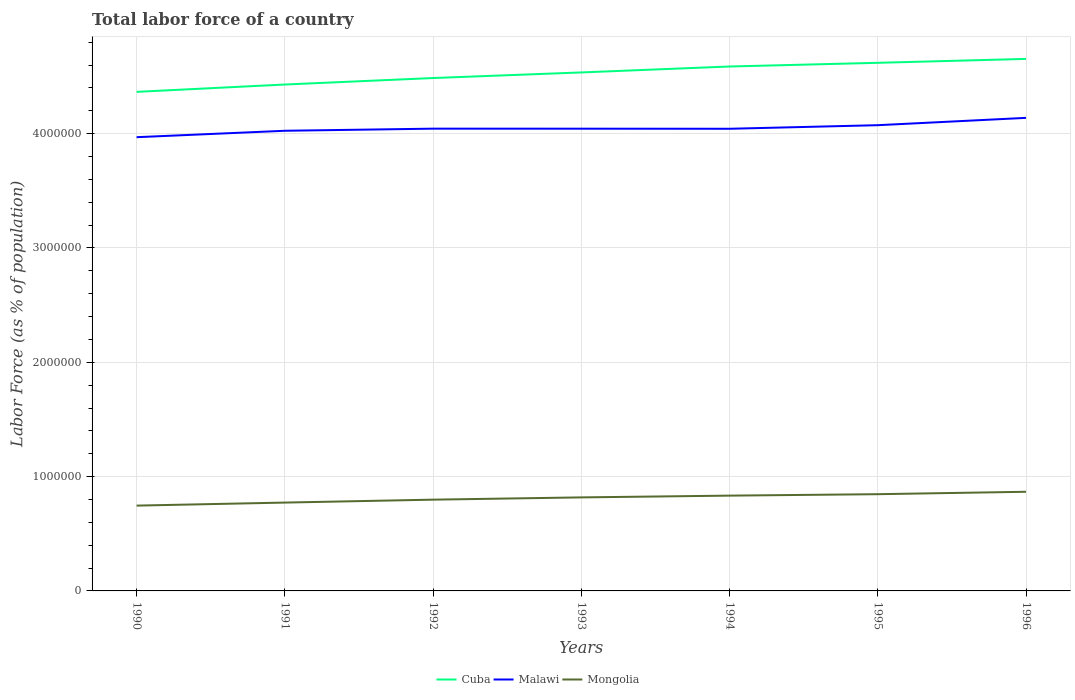How many different coloured lines are there?
Your response must be concise. 3. Does the line corresponding to Cuba intersect with the line corresponding to Malawi?
Your response must be concise. No. Across all years, what is the maximum percentage of labor force in Malawi?
Give a very brief answer. 3.97e+06. In which year was the percentage of labor force in Cuba maximum?
Your answer should be very brief. 1990. What is the total percentage of labor force in Malawi in the graph?
Offer a terse response. 359. What is the difference between the highest and the second highest percentage of labor force in Cuba?
Make the answer very short. 2.88e+05. Does the graph contain any zero values?
Give a very brief answer. No. Does the graph contain grids?
Provide a short and direct response. Yes. What is the title of the graph?
Offer a very short reply. Total labor force of a country. Does "Albania" appear as one of the legend labels in the graph?
Offer a very short reply. No. What is the label or title of the X-axis?
Your answer should be compact. Years. What is the label or title of the Y-axis?
Your answer should be very brief. Labor Force (as % of population). What is the Labor Force (as % of population) in Cuba in 1990?
Make the answer very short. 4.37e+06. What is the Labor Force (as % of population) in Malawi in 1990?
Offer a very short reply. 3.97e+06. What is the Labor Force (as % of population) in Mongolia in 1990?
Your response must be concise. 7.46e+05. What is the Labor Force (as % of population) in Cuba in 1991?
Keep it short and to the point. 4.43e+06. What is the Labor Force (as % of population) of Malawi in 1991?
Make the answer very short. 4.03e+06. What is the Labor Force (as % of population) of Mongolia in 1991?
Provide a short and direct response. 7.73e+05. What is the Labor Force (as % of population) in Cuba in 1992?
Offer a terse response. 4.49e+06. What is the Labor Force (as % of population) of Malawi in 1992?
Your response must be concise. 4.04e+06. What is the Labor Force (as % of population) in Mongolia in 1992?
Provide a short and direct response. 7.98e+05. What is the Labor Force (as % of population) of Cuba in 1993?
Keep it short and to the point. 4.54e+06. What is the Labor Force (as % of population) of Malawi in 1993?
Give a very brief answer. 4.04e+06. What is the Labor Force (as % of population) of Mongolia in 1993?
Keep it short and to the point. 8.18e+05. What is the Labor Force (as % of population) of Cuba in 1994?
Provide a succinct answer. 4.59e+06. What is the Labor Force (as % of population) of Malawi in 1994?
Provide a short and direct response. 4.04e+06. What is the Labor Force (as % of population) of Mongolia in 1994?
Ensure brevity in your answer.  8.34e+05. What is the Labor Force (as % of population) of Cuba in 1995?
Your answer should be compact. 4.62e+06. What is the Labor Force (as % of population) in Malawi in 1995?
Make the answer very short. 4.07e+06. What is the Labor Force (as % of population) of Mongolia in 1995?
Offer a very short reply. 8.46e+05. What is the Labor Force (as % of population) in Cuba in 1996?
Provide a succinct answer. 4.65e+06. What is the Labor Force (as % of population) in Malawi in 1996?
Offer a very short reply. 4.14e+06. What is the Labor Force (as % of population) of Mongolia in 1996?
Make the answer very short. 8.67e+05. Across all years, what is the maximum Labor Force (as % of population) of Cuba?
Provide a succinct answer. 4.65e+06. Across all years, what is the maximum Labor Force (as % of population) of Malawi?
Offer a terse response. 4.14e+06. Across all years, what is the maximum Labor Force (as % of population) in Mongolia?
Ensure brevity in your answer.  8.67e+05. Across all years, what is the minimum Labor Force (as % of population) of Cuba?
Keep it short and to the point. 4.37e+06. Across all years, what is the minimum Labor Force (as % of population) in Malawi?
Your answer should be very brief. 3.97e+06. Across all years, what is the minimum Labor Force (as % of population) of Mongolia?
Your response must be concise. 7.46e+05. What is the total Labor Force (as % of population) of Cuba in the graph?
Provide a succinct answer. 3.17e+07. What is the total Labor Force (as % of population) in Malawi in the graph?
Your response must be concise. 2.83e+07. What is the total Labor Force (as % of population) of Mongolia in the graph?
Your response must be concise. 5.68e+06. What is the difference between the Labor Force (as % of population) in Cuba in 1990 and that in 1991?
Ensure brevity in your answer.  -6.43e+04. What is the difference between the Labor Force (as % of population) in Malawi in 1990 and that in 1991?
Make the answer very short. -5.61e+04. What is the difference between the Labor Force (as % of population) in Mongolia in 1990 and that in 1991?
Provide a short and direct response. -2.65e+04. What is the difference between the Labor Force (as % of population) of Cuba in 1990 and that in 1992?
Your answer should be very brief. -1.21e+05. What is the difference between the Labor Force (as % of population) of Malawi in 1990 and that in 1992?
Make the answer very short. -7.47e+04. What is the difference between the Labor Force (as % of population) in Mongolia in 1990 and that in 1992?
Offer a terse response. -5.20e+04. What is the difference between the Labor Force (as % of population) of Cuba in 1990 and that in 1993?
Ensure brevity in your answer.  -1.70e+05. What is the difference between the Labor Force (as % of population) in Malawi in 1990 and that in 1993?
Provide a short and direct response. -7.43e+04. What is the difference between the Labor Force (as % of population) in Mongolia in 1990 and that in 1993?
Offer a very short reply. -7.19e+04. What is the difference between the Labor Force (as % of population) of Cuba in 1990 and that in 1994?
Give a very brief answer. -2.22e+05. What is the difference between the Labor Force (as % of population) of Malawi in 1990 and that in 1994?
Offer a very short reply. -7.36e+04. What is the difference between the Labor Force (as % of population) in Mongolia in 1990 and that in 1994?
Offer a terse response. -8.73e+04. What is the difference between the Labor Force (as % of population) in Cuba in 1990 and that in 1995?
Your answer should be very brief. -2.54e+05. What is the difference between the Labor Force (as % of population) of Malawi in 1990 and that in 1995?
Your response must be concise. -1.05e+05. What is the difference between the Labor Force (as % of population) in Mongolia in 1990 and that in 1995?
Your answer should be very brief. -9.99e+04. What is the difference between the Labor Force (as % of population) in Cuba in 1990 and that in 1996?
Provide a short and direct response. -2.88e+05. What is the difference between the Labor Force (as % of population) of Malawi in 1990 and that in 1996?
Your answer should be compact. -1.69e+05. What is the difference between the Labor Force (as % of population) in Mongolia in 1990 and that in 1996?
Offer a terse response. -1.21e+05. What is the difference between the Labor Force (as % of population) of Cuba in 1991 and that in 1992?
Give a very brief answer. -5.67e+04. What is the difference between the Labor Force (as % of population) in Malawi in 1991 and that in 1992?
Ensure brevity in your answer.  -1.86e+04. What is the difference between the Labor Force (as % of population) in Mongolia in 1991 and that in 1992?
Keep it short and to the point. -2.54e+04. What is the difference between the Labor Force (as % of population) of Cuba in 1991 and that in 1993?
Your response must be concise. -1.06e+05. What is the difference between the Labor Force (as % of population) in Malawi in 1991 and that in 1993?
Offer a terse response. -1.82e+04. What is the difference between the Labor Force (as % of population) of Mongolia in 1991 and that in 1993?
Provide a short and direct response. -4.54e+04. What is the difference between the Labor Force (as % of population) in Cuba in 1991 and that in 1994?
Your answer should be compact. -1.58e+05. What is the difference between the Labor Force (as % of population) in Malawi in 1991 and that in 1994?
Your answer should be compact. -1.75e+04. What is the difference between the Labor Force (as % of population) in Mongolia in 1991 and that in 1994?
Your response must be concise. -6.08e+04. What is the difference between the Labor Force (as % of population) of Cuba in 1991 and that in 1995?
Offer a very short reply. -1.90e+05. What is the difference between the Labor Force (as % of population) in Malawi in 1991 and that in 1995?
Make the answer very short. -4.89e+04. What is the difference between the Labor Force (as % of population) in Mongolia in 1991 and that in 1995?
Offer a very short reply. -7.34e+04. What is the difference between the Labor Force (as % of population) of Cuba in 1991 and that in 1996?
Ensure brevity in your answer.  -2.24e+05. What is the difference between the Labor Force (as % of population) in Malawi in 1991 and that in 1996?
Your answer should be very brief. -1.13e+05. What is the difference between the Labor Force (as % of population) of Mongolia in 1991 and that in 1996?
Give a very brief answer. -9.45e+04. What is the difference between the Labor Force (as % of population) in Cuba in 1992 and that in 1993?
Provide a short and direct response. -4.89e+04. What is the difference between the Labor Force (as % of population) in Malawi in 1992 and that in 1993?
Provide a succinct answer. 359. What is the difference between the Labor Force (as % of population) of Mongolia in 1992 and that in 1993?
Your response must be concise. -1.99e+04. What is the difference between the Labor Force (as % of population) in Cuba in 1992 and that in 1994?
Keep it short and to the point. -1.01e+05. What is the difference between the Labor Force (as % of population) in Malawi in 1992 and that in 1994?
Give a very brief answer. 1039. What is the difference between the Labor Force (as % of population) in Mongolia in 1992 and that in 1994?
Ensure brevity in your answer.  -3.53e+04. What is the difference between the Labor Force (as % of population) in Cuba in 1992 and that in 1995?
Make the answer very short. -1.33e+05. What is the difference between the Labor Force (as % of population) of Malawi in 1992 and that in 1995?
Provide a succinct answer. -3.03e+04. What is the difference between the Labor Force (as % of population) in Mongolia in 1992 and that in 1995?
Offer a very short reply. -4.79e+04. What is the difference between the Labor Force (as % of population) in Cuba in 1992 and that in 1996?
Make the answer very short. -1.67e+05. What is the difference between the Labor Force (as % of population) of Malawi in 1992 and that in 1996?
Provide a succinct answer. -9.44e+04. What is the difference between the Labor Force (as % of population) of Mongolia in 1992 and that in 1996?
Your answer should be very brief. -6.90e+04. What is the difference between the Labor Force (as % of population) of Cuba in 1993 and that in 1994?
Make the answer very short. -5.19e+04. What is the difference between the Labor Force (as % of population) of Malawi in 1993 and that in 1994?
Offer a terse response. 680. What is the difference between the Labor Force (as % of population) in Mongolia in 1993 and that in 1994?
Keep it short and to the point. -1.54e+04. What is the difference between the Labor Force (as % of population) of Cuba in 1993 and that in 1995?
Provide a short and direct response. -8.42e+04. What is the difference between the Labor Force (as % of population) of Malawi in 1993 and that in 1995?
Your response must be concise. -3.06e+04. What is the difference between the Labor Force (as % of population) of Mongolia in 1993 and that in 1995?
Make the answer very short. -2.80e+04. What is the difference between the Labor Force (as % of population) of Cuba in 1993 and that in 1996?
Provide a succinct answer. -1.18e+05. What is the difference between the Labor Force (as % of population) of Malawi in 1993 and that in 1996?
Ensure brevity in your answer.  -9.48e+04. What is the difference between the Labor Force (as % of population) in Mongolia in 1993 and that in 1996?
Your response must be concise. -4.91e+04. What is the difference between the Labor Force (as % of population) of Cuba in 1994 and that in 1995?
Give a very brief answer. -3.23e+04. What is the difference between the Labor Force (as % of population) in Malawi in 1994 and that in 1995?
Offer a very short reply. -3.13e+04. What is the difference between the Labor Force (as % of population) of Mongolia in 1994 and that in 1995?
Your answer should be very brief. -1.26e+04. What is the difference between the Labor Force (as % of population) of Cuba in 1994 and that in 1996?
Your answer should be very brief. -6.64e+04. What is the difference between the Labor Force (as % of population) of Malawi in 1994 and that in 1996?
Provide a succinct answer. -9.55e+04. What is the difference between the Labor Force (as % of population) of Mongolia in 1994 and that in 1996?
Offer a terse response. -3.37e+04. What is the difference between the Labor Force (as % of population) in Cuba in 1995 and that in 1996?
Your answer should be compact. -3.42e+04. What is the difference between the Labor Force (as % of population) in Malawi in 1995 and that in 1996?
Your answer should be compact. -6.41e+04. What is the difference between the Labor Force (as % of population) in Mongolia in 1995 and that in 1996?
Keep it short and to the point. -2.11e+04. What is the difference between the Labor Force (as % of population) of Cuba in 1990 and the Labor Force (as % of population) of Malawi in 1991?
Keep it short and to the point. 3.40e+05. What is the difference between the Labor Force (as % of population) of Cuba in 1990 and the Labor Force (as % of population) of Mongolia in 1991?
Your response must be concise. 3.59e+06. What is the difference between the Labor Force (as % of population) of Malawi in 1990 and the Labor Force (as % of population) of Mongolia in 1991?
Provide a short and direct response. 3.20e+06. What is the difference between the Labor Force (as % of population) in Cuba in 1990 and the Labor Force (as % of population) in Malawi in 1992?
Offer a very short reply. 3.22e+05. What is the difference between the Labor Force (as % of population) in Cuba in 1990 and the Labor Force (as % of population) in Mongolia in 1992?
Make the answer very short. 3.57e+06. What is the difference between the Labor Force (as % of population) of Malawi in 1990 and the Labor Force (as % of population) of Mongolia in 1992?
Keep it short and to the point. 3.17e+06. What is the difference between the Labor Force (as % of population) in Cuba in 1990 and the Labor Force (as % of population) in Malawi in 1993?
Your answer should be very brief. 3.22e+05. What is the difference between the Labor Force (as % of population) of Cuba in 1990 and the Labor Force (as % of population) of Mongolia in 1993?
Ensure brevity in your answer.  3.55e+06. What is the difference between the Labor Force (as % of population) of Malawi in 1990 and the Labor Force (as % of population) of Mongolia in 1993?
Your answer should be compact. 3.15e+06. What is the difference between the Labor Force (as % of population) in Cuba in 1990 and the Labor Force (as % of population) in Malawi in 1994?
Provide a succinct answer. 3.23e+05. What is the difference between the Labor Force (as % of population) of Cuba in 1990 and the Labor Force (as % of population) of Mongolia in 1994?
Offer a terse response. 3.53e+06. What is the difference between the Labor Force (as % of population) in Malawi in 1990 and the Labor Force (as % of population) in Mongolia in 1994?
Your response must be concise. 3.14e+06. What is the difference between the Labor Force (as % of population) in Cuba in 1990 and the Labor Force (as % of population) in Malawi in 1995?
Provide a short and direct response. 2.92e+05. What is the difference between the Labor Force (as % of population) of Cuba in 1990 and the Labor Force (as % of population) of Mongolia in 1995?
Keep it short and to the point. 3.52e+06. What is the difference between the Labor Force (as % of population) in Malawi in 1990 and the Labor Force (as % of population) in Mongolia in 1995?
Give a very brief answer. 3.12e+06. What is the difference between the Labor Force (as % of population) of Cuba in 1990 and the Labor Force (as % of population) of Malawi in 1996?
Your answer should be compact. 2.27e+05. What is the difference between the Labor Force (as % of population) in Cuba in 1990 and the Labor Force (as % of population) in Mongolia in 1996?
Offer a very short reply. 3.50e+06. What is the difference between the Labor Force (as % of population) in Malawi in 1990 and the Labor Force (as % of population) in Mongolia in 1996?
Your answer should be compact. 3.10e+06. What is the difference between the Labor Force (as % of population) in Cuba in 1991 and the Labor Force (as % of population) in Malawi in 1992?
Your answer should be very brief. 3.86e+05. What is the difference between the Labor Force (as % of population) of Cuba in 1991 and the Labor Force (as % of population) of Mongolia in 1992?
Offer a terse response. 3.63e+06. What is the difference between the Labor Force (as % of population) of Malawi in 1991 and the Labor Force (as % of population) of Mongolia in 1992?
Your answer should be compact. 3.23e+06. What is the difference between the Labor Force (as % of population) of Cuba in 1991 and the Labor Force (as % of population) of Malawi in 1993?
Provide a succinct answer. 3.86e+05. What is the difference between the Labor Force (as % of population) in Cuba in 1991 and the Labor Force (as % of population) in Mongolia in 1993?
Your answer should be very brief. 3.61e+06. What is the difference between the Labor Force (as % of population) of Malawi in 1991 and the Labor Force (as % of population) of Mongolia in 1993?
Make the answer very short. 3.21e+06. What is the difference between the Labor Force (as % of population) of Cuba in 1991 and the Labor Force (as % of population) of Malawi in 1994?
Your answer should be compact. 3.87e+05. What is the difference between the Labor Force (as % of population) of Cuba in 1991 and the Labor Force (as % of population) of Mongolia in 1994?
Keep it short and to the point. 3.60e+06. What is the difference between the Labor Force (as % of population) of Malawi in 1991 and the Labor Force (as % of population) of Mongolia in 1994?
Offer a very short reply. 3.19e+06. What is the difference between the Labor Force (as % of population) of Cuba in 1991 and the Labor Force (as % of population) of Malawi in 1995?
Offer a terse response. 3.56e+05. What is the difference between the Labor Force (as % of population) of Cuba in 1991 and the Labor Force (as % of population) of Mongolia in 1995?
Make the answer very short. 3.58e+06. What is the difference between the Labor Force (as % of population) of Malawi in 1991 and the Labor Force (as % of population) of Mongolia in 1995?
Ensure brevity in your answer.  3.18e+06. What is the difference between the Labor Force (as % of population) of Cuba in 1991 and the Labor Force (as % of population) of Malawi in 1996?
Your answer should be compact. 2.92e+05. What is the difference between the Labor Force (as % of population) of Cuba in 1991 and the Labor Force (as % of population) of Mongolia in 1996?
Offer a very short reply. 3.56e+06. What is the difference between the Labor Force (as % of population) of Malawi in 1991 and the Labor Force (as % of population) of Mongolia in 1996?
Provide a succinct answer. 3.16e+06. What is the difference between the Labor Force (as % of population) in Cuba in 1992 and the Labor Force (as % of population) in Malawi in 1993?
Ensure brevity in your answer.  4.43e+05. What is the difference between the Labor Force (as % of population) in Cuba in 1992 and the Labor Force (as % of population) in Mongolia in 1993?
Keep it short and to the point. 3.67e+06. What is the difference between the Labor Force (as % of population) in Malawi in 1992 and the Labor Force (as % of population) in Mongolia in 1993?
Offer a terse response. 3.23e+06. What is the difference between the Labor Force (as % of population) in Cuba in 1992 and the Labor Force (as % of population) in Malawi in 1994?
Give a very brief answer. 4.44e+05. What is the difference between the Labor Force (as % of population) of Cuba in 1992 and the Labor Force (as % of population) of Mongolia in 1994?
Provide a succinct answer. 3.65e+06. What is the difference between the Labor Force (as % of population) of Malawi in 1992 and the Labor Force (as % of population) of Mongolia in 1994?
Provide a short and direct response. 3.21e+06. What is the difference between the Labor Force (as % of population) of Cuba in 1992 and the Labor Force (as % of population) of Malawi in 1995?
Your response must be concise. 4.13e+05. What is the difference between the Labor Force (as % of population) in Cuba in 1992 and the Labor Force (as % of population) in Mongolia in 1995?
Offer a very short reply. 3.64e+06. What is the difference between the Labor Force (as % of population) in Malawi in 1992 and the Labor Force (as % of population) in Mongolia in 1995?
Keep it short and to the point. 3.20e+06. What is the difference between the Labor Force (as % of population) of Cuba in 1992 and the Labor Force (as % of population) of Malawi in 1996?
Provide a short and direct response. 3.48e+05. What is the difference between the Labor Force (as % of population) of Cuba in 1992 and the Labor Force (as % of population) of Mongolia in 1996?
Your answer should be compact. 3.62e+06. What is the difference between the Labor Force (as % of population) in Malawi in 1992 and the Labor Force (as % of population) in Mongolia in 1996?
Your response must be concise. 3.18e+06. What is the difference between the Labor Force (as % of population) of Cuba in 1993 and the Labor Force (as % of population) of Malawi in 1994?
Your answer should be compact. 4.93e+05. What is the difference between the Labor Force (as % of population) in Cuba in 1993 and the Labor Force (as % of population) in Mongolia in 1994?
Provide a succinct answer. 3.70e+06. What is the difference between the Labor Force (as % of population) of Malawi in 1993 and the Labor Force (as % of population) of Mongolia in 1994?
Ensure brevity in your answer.  3.21e+06. What is the difference between the Labor Force (as % of population) in Cuba in 1993 and the Labor Force (as % of population) in Malawi in 1995?
Ensure brevity in your answer.  4.61e+05. What is the difference between the Labor Force (as % of population) of Cuba in 1993 and the Labor Force (as % of population) of Mongolia in 1995?
Offer a terse response. 3.69e+06. What is the difference between the Labor Force (as % of population) of Malawi in 1993 and the Labor Force (as % of population) of Mongolia in 1995?
Offer a terse response. 3.20e+06. What is the difference between the Labor Force (as % of population) in Cuba in 1993 and the Labor Force (as % of population) in Malawi in 1996?
Keep it short and to the point. 3.97e+05. What is the difference between the Labor Force (as % of population) of Cuba in 1993 and the Labor Force (as % of population) of Mongolia in 1996?
Keep it short and to the point. 3.67e+06. What is the difference between the Labor Force (as % of population) of Malawi in 1993 and the Labor Force (as % of population) of Mongolia in 1996?
Your answer should be very brief. 3.18e+06. What is the difference between the Labor Force (as % of population) in Cuba in 1994 and the Labor Force (as % of population) in Malawi in 1995?
Provide a short and direct response. 5.13e+05. What is the difference between the Labor Force (as % of population) of Cuba in 1994 and the Labor Force (as % of population) of Mongolia in 1995?
Your answer should be very brief. 3.74e+06. What is the difference between the Labor Force (as % of population) of Malawi in 1994 and the Labor Force (as % of population) of Mongolia in 1995?
Your answer should be compact. 3.20e+06. What is the difference between the Labor Force (as % of population) in Cuba in 1994 and the Labor Force (as % of population) in Malawi in 1996?
Ensure brevity in your answer.  4.49e+05. What is the difference between the Labor Force (as % of population) of Cuba in 1994 and the Labor Force (as % of population) of Mongolia in 1996?
Your response must be concise. 3.72e+06. What is the difference between the Labor Force (as % of population) of Malawi in 1994 and the Labor Force (as % of population) of Mongolia in 1996?
Ensure brevity in your answer.  3.18e+06. What is the difference between the Labor Force (as % of population) of Cuba in 1995 and the Labor Force (as % of population) of Malawi in 1996?
Keep it short and to the point. 4.82e+05. What is the difference between the Labor Force (as % of population) of Cuba in 1995 and the Labor Force (as % of population) of Mongolia in 1996?
Ensure brevity in your answer.  3.75e+06. What is the difference between the Labor Force (as % of population) of Malawi in 1995 and the Labor Force (as % of population) of Mongolia in 1996?
Offer a very short reply. 3.21e+06. What is the average Labor Force (as % of population) in Cuba per year?
Give a very brief answer. 4.53e+06. What is the average Labor Force (as % of population) in Malawi per year?
Your response must be concise. 4.05e+06. What is the average Labor Force (as % of population) in Mongolia per year?
Provide a succinct answer. 8.12e+05. In the year 1990, what is the difference between the Labor Force (as % of population) of Cuba and Labor Force (as % of population) of Malawi?
Your answer should be compact. 3.96e+05. In the year 1990, what is the difference between the Labor Force (as % of population) in Cuba and Labor Force (as % of population) in Mongolia?
Provide a succinct answer. 3.62e+06. In the year 1990, what is the difference between the Labor Force (as % of population) of Malawi and Labor Force (as % of population) of Mongolia?
Your response must be concise. 3.22e+06. In the year 1991, what is the difference between the Labor Force (as % of population) in Cuba and Labor Force (as % of population) in Malawi?
Give a very brief answer. 4.05e+05. In the year 1991, what is the difference between the Labor Force (as % of population) of Cuba and Labor Force (as % of population) of Mongolia?
Give a very brief answer. 3.66e+06. In the year 1991, what is the difference between the Labor Force (as % of population) of Malawi and Labor Force (as % of population) of Mongolia?
Offer a very short reply. 3.25e+06. In the year 1992, what is the difference between the Labor Force (as % of population) of Cuba and Labor Force (as % of population) of Malawi?
Provide a short and direct response. 4.43e+05. In the year 1992, what is the difference between the Labor Force (as % of population) in Cuba and Labor Force (as % of population) in Mongolia?
Provide a short and direct response. 3.69e+06. In the year 1992, what is the difference between the Labor Force (as % of population) of Malawi and Labor Force (as % of population) of Mongolia?
Make the answer very short. 3.25e+06. In the year 1993, what is the difference between the Labor Force (as % of population) in Cuba and Labor Force (as % of population) in Malawi?
Ensure brevity in your answer.  4.92e+05. In the year 1993, what is the difference between the Labor Force (as % of population) in Cuba and Labor Force (as % of population) in Mongolia?
Provide a short and direct response. 3.72e+06. In the year 1993, what is the difference between the Labor Force (as % of population) in Malawi and Labor Force (as % of population) in Mongolia?
Keep it short and to the point. 3.23e+06. In the year 1994, what is the difference between the Labor Force (as % of population) of Cuba and Labor Force (as % of population) of Malawi?
Your answer should be compact. 5.45e+05. In the year 1994, what is the difference between the Labor Force (as % of population) of Cuba and Labor Force (as % of population) of Mongolia?
Offer a very short reply. 3.75e+06. In the year 1994, what is the difference between the Labor Force (as % of population) in Malawi and Labor Force (as % of population) in Mongolia?
Your answer should be very brief. 3.21e+06. In the year 1995, what is the difference between the Labor Force (as % of population) of Cuba and Labor Force (as % of population) of Malawi?
Your answer should be compact. 5.46e+05. In the year 1995, what is the difference between the Labor Force (as % of population) in Cuba and Labor Force (as % of population) in Mongolia?
Your answer should be compact. 3.77e+06. In the year 1995, what is the difference between the Labor Force (as % of population) in Malawi and Labor Force (as % of population) in Mongolia?
Make the answer very short. 3.23e+06. In the year 1996, what is the difference between the Labor Force (as % of population) in Cuba and Labor Force (as % of population) in Malawi?
Your answer should be compact. 5.16e+05. In the year 1996, what is the difference between the Labor Force (as % of population) in Cuba and Labor Force (as % of population) in Mongolia?
Your answer should be compact. 3.79e+06. In the year 1996, what is the difference between the Labor Force (as % of population) in Malawi and Labor Force (as % of population) in Mongolia?
Keep it short and to the point. 3.27e+06. What is the ratio of the Labor Force (as % of population) in Cuba in 1990 to that in 1991?
Your answer should be very brief. 0.99. What is the ratio of the Labor Force (as % of population) of Malawi in 1990 to that in 1991?
Offer a terse response. 0.99. What is the ratio of the Labor Force (as % of population) in Mongolia in 1990 to that in 1991?
Keep it short and to the point. 0.97. What is the ratio of the Labor Force (as % of population) in Malawi in 1990 to that in 1992?
Make the answer very short. 0.98. What is the ratio of the Labor Force (as % of population) of Mongolia in 1990 to that in 1992?
Give a very brief answer. 0.93. What is the ratio of the Labor Force (as % of population) in Cuba in 1990 to that in 1993?
Your response must be concise. 0.96. What is the ratio of the Labor Force (as % of population) in Malawi in 1990 to that in 1993?
Offer a very short reply. 0.98. What is the ratio of the Labor Force (as % of population) of Mongolia in 1990 to that in 1993?
Provide a short and direct response. 0.91. What is the ratio of the Labor Force (as % of population) of Cuba in 1990 to that in 1994?
Offer a terse response. 0.95. What is the ratio of the Labor Force (as % of population) of Malawi in 1990 to that in 1994?
Ensure brevity in your answer.  0.98. What is the ratio of the Labor Force (as % of population) of Mongolia in 1990 to that in 1994?
Your answer should be compact. 0.9. What is the ratio of the Labor Force (as % of population) of Cuba in 1990 to that in 1995?
Give a very brief answer. 0.94. What is the ratio of the Labor Force (as % of population) of Malawi in 1990 to that in 1995?
Your answer should be compact. 0.97. What is the ratio of the Labor Force (as % of population) of Mongolia in 1990 to that in 1995?
Provide a short and direct response. 0.88. What is the ratio of the Labor Force (as % of population) in Cuba in 1990 to that in 1996?
Keep it short and to the point. 0.94. What is the ratio of the Labor Force (as % of population) in Malawi in 1990 to that in 1996?
Offer a very short reply. 0.96. What is the ratio of the Labor Force (as % of population) in Mongolia in 1990 to that in 1996?
Provide a short and direct response. 0.86. What is the ratio of the Labor Force (as % of population) of Cuba in 1991 to that in 1992?
Make the answer very short. 0.99. What is the ratio of the Labor Force (as % of population) of Malawi in 1991 to that in 1992?
Offer a very short reply. 1. What is the ratio of the Labor Force (as % of population) in Mongolia in 1991 to that in 1992?
Your answer should be compact. 0.97. What is the ratio of the Labor Force (as % of population) of Cuba in 1991 to that in 1993?
Ensure brevity in your answer.  0.98. What is the ratio of the Labor Force (as % of population) of Malawi in 1991 to that in 1993?
Provide a short and direct response. 1. What is the ratio of the Labor Force (as % of population) of Mongolia in 1991 to that in 1993?
Your answer should be compact. 0.94. What is the ratio of the Labor Force (as % of population) in Cuba in 1991 to that in 1994?
Offer a terse response. 0.97. What is the ratio of the Labor Force (as % of population) of Malawi in 1991 to that in 1994?
Provide a short and direct response. 1. What is the ratio of the Labor Force (as % of population) of Mongolia in 1991 to that in 1994?
Give a very brief answer. 0.93. What is the ratio of the Labor Force (as % of population) of Cuba in 1991 to that in 1995?
Ensure brevity in your answer.  0.96. What is the ratio of the Labor Force (as % of population) in Mongolia in 1991 to that in 1995?
Offer a terse response. 0.91. What is the ratio of the Labor Force (as % of population) of Cuba in 1991 to that in 1996?
Offer a very short reply. 0.95. What is the ratio of the Labor Force (as % of population) of Malawi in 1991 to that in 1996?
Provide a short and direct response. 0.97. What is the ratio of the Labor Force (as % of population) of Mongolia in 1991 to that in 1996?
Your answer should be very brief. 0.89. What is the ratio of the Labor Force (as % of population) of Malawi in 1992 to that in 1993?
Offer a very short reply. 1. What is the ratio of the Labor Force (as % of population) in Mongolia in 1992 to that in 1993?
Make the answer very short. 0.98. What is the ratio of the Labor Force (as % of population) in Cuba in 1992 to that in 1994?
Your answer should be very brief. 0.98. What is the ratio of the Labor Force (as % of population) in Malawi in 1992 to that in 1994?
Give a very brief answer. 1. What is the ratio of the Labor Force (as % of population) of Mongolia in 1992 to that in 1994?
Keep it short and to the point. 0.96. What is the ratio of the Labor Force (as % of population) of Cuba in 1992 to that in 1995?
Provide a short and direct response. 0.97. What is the ratio of the Labor Force (as % of population) in Malawi in 1992 to that in 1995?
Ensure brevity in your answer.  0.99. What is the ratio of the Labor Force (as % of population) in Mongolia in 1992 to that in 1995?
Make the answer very short. 0.94. What is the ratio of the Labor Force (as % of population) in Cuba in 1992 to that in 1996?
Give a very brief answer. 0.96. What is the ratio of the Labor Force (as % of population) in Malawi in 1992 to that in 1996?
Your answer should be very brief. 0.98. What is the ratio of the Labor Force (as % of population) of Mongolia in 1992 to that in 1996?
Keep it short and to the point. 0.92. What is the ratio of the Labor Force (as % of population) in Cuba in 1993 to that in 1994?
Offer a very short reply. 0.99. What is the ratio of the Labor Force (as % of population) of Mongolia in 1993 to that in 1994?
Your answer should be compact. 0.98. What is the ratio of the Labor Force (as % of population) in Cuba in 1993 to that in 1995?
Offer a very short reply. 0.98. What is the ratio of the Labor Force (as % of population) of Mongolia in 1993 to that in 1995?
Provide a succinct answer. 0.97. What is the ratio of the Labor Force (as % of population) in Cuba in 1993 to that in 1996?
Ensure brevity in your answer.  0.97. What is the ratio of the Labor Force (as % of population) of Malawi in 1993 to that in 1996?
Ensure brevity in your answer.  0.98. What is the ratio of the Labor Force (as % of population) of Mongolia in 1993 to that in 1996?
Your answer should be compact. 0.94. What is the ratio of the Labor Force (as % of population) in Cuba in 1994 to that in 1995?
Your response must be concise. 0.99. What is the ratio of the Labor Force (as % of population) of Mongolia in 1994 to that in 1995?
Give a very brief answer. 0.99. What is the ratio of the Labor Force (as % of population) in Cuba in 1994 to that in 1996?
Your answer should be compact. 0.99. What is the ratio of the Labor Force (as % of population) in Malawi in 1994 to that in 1996?
Your answer should be very brief. 0.98. What is the ratio of the Labor Force (as % of population) in Mongolia in 1994 to that in 1996?
Provide a short and direct response. 0.96. What is the ratio of the Labor Force (as % of population) in Cuba in 1995 to that in 1996?
Ensure brevity in your answer.  0.99. What is the ratio of the Labor Force (as % of population) of Malawi in 1995 to that in 1996?
Ensure brevity in your answer.  0.98. What is the ratio of the Labor Force (as % of population) in Mongolia in 1995 to that in 1996?
Your answer should be compact. 0.98. What is the difference between the highest and the second highest Labor Force (as % of population) of Cuba?
Your answer should be very brief. 3.42e+04. What is the difference between the highest and the second highest Labor Force (as % of population) in Malawi?
Provide a succinct answer. 6.41e+04. What is the difference between the highest and the second highest Labor Force (as % of population) in Mongolia?
Keep it short and to the point. 2.11e+04. What is the difference between the highest and the lowest Labor Force (as % of population) in Cuba?
Make the answer very short. 2.88e+05. What is the difference between the highest and the lowest Labor Force (as % of population) of Malawi?
Give a very brief answer. 1.69e+05. What is the difference between the highest and the lowest Labor Force (as % of population) of Mongolia?
Your answer should be compact. 1.21e+05. 